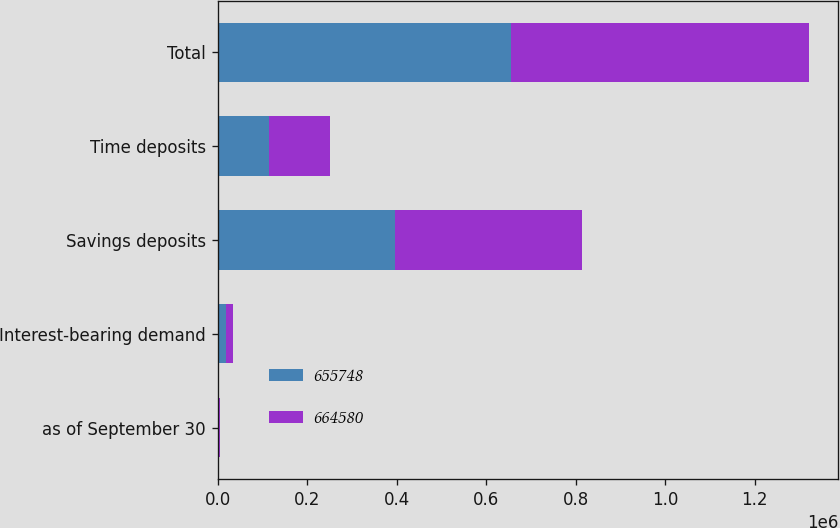Convert chart. <chart><loc_0><loc_0><loc_500><loc_500><stacked_bar_chart><ecel><fcel>as of September 30<fcel>Interest-bearing demand<fcel>Savings deposits<fcel>Time deposits<fcel>Total<nl><fcel>655748<fcel>2010<fcel>18555<fcel>397078<fcel>115279<fcel>655748<nl><fcel>664580<fcel>2009<fcel>16546<fcel>415767<fcel>134621<fcel>664580<nl></chart> 